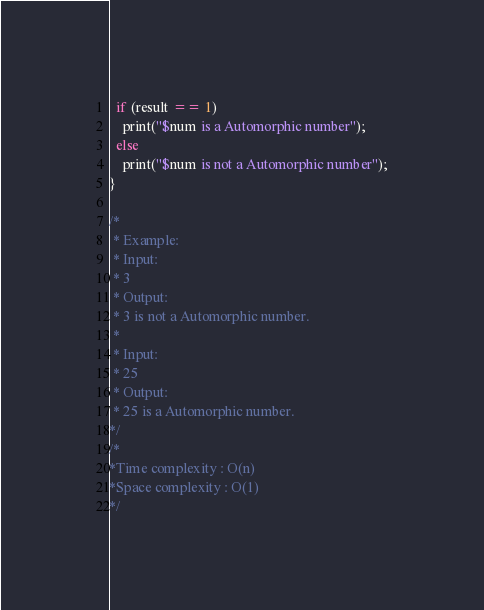Convert code to text. <code><loc_0><loc_0><loc_500><loc_500><_Dart_>  if (result == 1)
    print("$num is a Automorphic number");
  else
    print("$num is not a Automorphic number");
}

/*
 * Example:
 * Input:
 * 3
 * Output:
 * 3 is not a Automorphic number.
 * 
 * Input:
 * 25
 * Output:
 * 25 is a Automorphic number.
*/
/*
*Time complexity : O(n) 
*Space complexity : O(1)
*/
</code> 